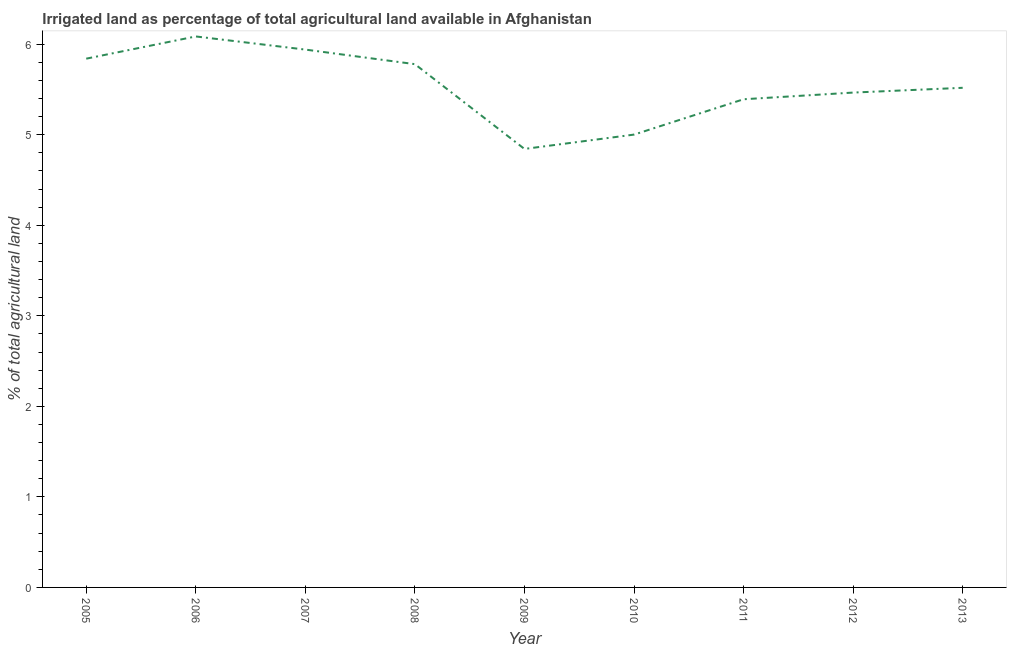What is the percentage of agricultural irrigated land in 2006?
Your answer should be very brief. 6.09. Across all years, what is the maximum percentage of agricultural irrigated land?
Your answer should be very brief. 6.09. Across all years, what is the minimum percentage of agricultural irrigated land?
Provide a short and direct response. 4.84. In which year was the percentage of agricultural irrigated land minimum?
Keep it short and to the point. 2009. What is the sum of the percentage of agricultural irrigated land?
Your answer should be compact. 49.87. What is the difference between the percentage of agricultural irrigated land in 2009 and 2010?
Offer a terse response. -0.16. What is the average percentage of agricultural irrigated land per year?
Ensure brevity in your answer.  5.54. What is the median percentage of agricultural irrigated land?
Your answer should be very brief. 5.52. In how many years, is the percentage of agricultural irrigated land greater than 3.2 %?
Make the answer very short. 9. What is the ratio of the percentage of agricultural irrigated land in 2007 to that in 2010?
Keep it short and to the point. 1.19. Is the difference between the percentage of agricultural irrigated land in 2006 and 2011 greater than the difference between any two years?
Your answer should be very brief. No. What is the difference between the highest and the second highest percentage of agricultural irrigated land?
Provide a short and direct response. 0.15. What is the difference between the highest and the lowest percentage of agricultural irrigated land?
Keep it short and to the point. 1.24. Does the percentage of agricultural irrigated land monotonically increase over the years?
Offer a very short reply. No. How many years are there in the graph?
Offer a very short reply. 9. Does the graph contain any zero values?
Your response must be concise. No. Does the graph contain grids?
Make the answer very short. No. What is the title of the graph?
Your response must be concise. Irrigated land as percentage of total agricultural land available in Afghanistan. What is the label or title of the Y-axis?
Make the answer very short. % of total agricultural land. What is the % of total agricultural land in 2005?
Provide a short and direct response. 5.84. What is the % of total agricultural land of 2006?
Offer a very short reply. 6.09. What is the % of total agricultural land of 2007?
Your answer should be very brief. 5.94. What is the % of total agricultural land in 2008?
Make the answer very short. 5.78. What is the % of total agricultural land in 2009?
Ensure brevity in your answer.  4.84. What is the % of total agricultural land in 2010?
Provide a succinct answer. 5. What is the % of total agricultural land in 2011?
Offer a very short reply. 5.39. What is the % of total agricultural land in 2012?
Your answer should be very brief. 5.47. What is the % of total agricultural land of 2013?
Your response must be concise. 5.52. What is the difference between the % of total agricultural land in 2005 and 2006?
Provide a succinct answer. -0.25. What is the difference between the % of total agricultural land in 2005 and 2007?
Your response must be concise. -0.1. What is the difference between the % of total agricultural land in 2005 and 2008?
Give a very brief answer. 0.06. What is the difference between the % of total agricultural land in 2005 and 2010?
Your answer should be compact. 0.84. What is the difference between the % of total agricultural land in 2005 and 2011?
Your answer should be very brief. 0.45. What is the difference between the % of total agricultural land in 2005 and 2012?
Make the answer very short. 0.37. What is the difference between the % of total agricultural land in 2005 and 2013?
Provide a short and direct response. 0.32. What is the difference between the % of total agricultural land in 2006 and 2007?
Provide a short and direct response. 0.15. What is the difference between the % of total agricultural land in 2006 and 2008?
Keep it short and to the point. 0.31. What is the difference between the % of total agricultural land in 2006 and 2009?
Offer a very short reply. 1.24. What is the difference between the % of total agricultural land in 2006 and 2010?
Provide a succinct answer. 1.08. What is the difference between the % of total agricultural land in 2006 and 2011?
Keep it short and to the point. 0.69. What is the difference between the % of total agricultural land in 2006 and 2012?
Your answer should be very brief. 0.62. What is the difference between the % of total agricultural land in 2006 and 2013?
Make the answer very short. 0.57. What is the difference between the % of total agricultural land in 2007 and 2008?
Make the answer very short. 0.16. What is the difference between the % of total agricultural land in 2007 and 2009?
Ensure brevity in your answer.  1.1. What is the difference between the % of total agricultural land in 2007 and 2010?
Your response must be concise. 0.94. What is the difference between the % of total agricultural land in 2007 and 2011?
Make the answer very short. 0.55. What is the difference between the % of total agricultural land in 2007 and 2012?
Offer a terse response. 0.47. What is the difference between the % of total agricultural land in 2007 and 2013?
Ensure brevity in your answer.  0.42. What is the difference between the % of total agricultural land in 2008 and 2009?
Keep it short and to the point. 0.94. What is the difference between the % of total agricultural land in 2008 and 2010?
Keep it short and to the point. 0.78. What is the difference between the % of total agricultural land in 2008 and 2011?
Your response must be concise. 0.39. What is the difference between the % of total agricultural land in 2008 and 2012?
Keep it short and to the point. 0.31. What is the difference between the % of total agricultural land in 2008 and 2013?
Make the answer very short. 0.26. What is the difference between the % of total agricultural land in 2009 and 2010?
Your answer should be very brief. -0.16. What is the difference between the % of total agricultural land in 2009 and 2011?
Offer a very short reply. -0.55. What is the difference between the % of total agricultural land in 2009 and 2012?
Offer a terse response. -0.62. What is the difference between the % of total agricultural land in 2009 and 2013?
Offer a terse response. -0.68. What is the difference between the % of total agricultural land in 2010 and 2011?
Your answer should be very brief. -0.39. What is the difference between the % of total agricultural land in 2010 and 2012?
Give a very brief answer. -0.46. What is the difference between the % of total agricultural land in 2010 and 2013?
Ensure brevity in your answer.  -0.52. What is the difference between the % of total agricultural land in 2011 and 2012?
Give a very brief answer. -0.07. What is the difference between the % of total agricultural land in 2011 and 2013?
Your answer should be very brief. -0.13. What is the difference between the % of total agricultural land in 2012 and 2013?
Make the answer very short. -0.05. What is the ratio of the % of total agricultural land in 2005 to that in 2009?
Offer a terse response. 1.21. What is the ratio of the % of total agricultural land in 2005 to that in 2010?
Provide a succinct answer. 1.17. What is the ratio of the % of total agricultural land in 2005 to that in 2011?
Make the answer very short. 1.08. What is the ratio of the % of total agricultural land in 2005 to that in 2012?
Offer a terse response. 1.07. What is the ratio of the % of total agricultural land in 2005 to that in 2013?
Keep it short and to the point. 1.06. What is the ratio of the % of total agricultural land in 2006 to that in 2007?
Ensure brevity in your answer.  1.02. What is the ratio of the % of total agricultural land in 2006 to that in 2008?
Offer a terse response. 1.05. What is the ratio of the % of total agricultural land in 2006 to that in 2009?
Make the answer very short. 1.26. What is the ratio of the % of total agricultural land in 2006 to that in 2010?
Keep it short and to the point. 1.22. What is the ratio of the % of total agricultural land in 2006 to that in 2011?
Keep it short and to the point. 1.13. What is the ratio of the % of total agricultural land in 2006 to that in 2012?
Offer a very short reply. 1.11. What is the ratio of the % of total agricultural land in 2006 to that in 2013?
Give a very brief answer. 1.1. What is the ratio of the % of total agricultural land in 2007 to that in 2008?
Offer a terse response. 1.03. What is the ratio of the % of total agricultural land in 2007 to that in 2009?
Make the answer very short. 1.23. What is the ratio of the % of total agricultural land in 2007 to that in 2010?
Offer a very short reply. 1.19. What is the ratio of the % of total agricultural land in 2007 to that in 2011?
Provide a short and direct response. 1.1. What is the ratio of the % of total agricultural land in 2007 to that in 2012?
Provide a short and direct response. 1.09. What is the ratio of the % of total agricultural land in 2007 to that in 2013?
Make the answer very short. 1.08. What is the ratio of the % of total agricultural land in 2008 to that in 2009?
Keep it short and to the point. 1.19. What is the ratio of the % of total agricultural land in 2008 to that in 2010?
Your response must be concise. 1.16. What is the ratio of the % of total agricultural land in 2008 to that in 2011?
Offer a terse response. 1.07. What is the ratio of the % of total agricultural land in 2008 to that in 2012?
Your answer should be compact. 1.06. What is the ratio of the % of total agricultural land in 2008 to that in 2013?
Offer a terse response. 1.05. What is the ratio of the % of total agricultural land in 2009 to that in 2010?
Your answer should be very brief. 0.97. What is the ratio of the % of total agricultural land in 2009 to that in 2011?
Provide a succinct answer. 0.9. What is the ratio of the % of total agricultural land in 2009 to that in 2012?
Provide a succinct answer. 0.89. What is the ratio of the % of total agricultural land in 2009 to that in 2013?
Keep it short and to the point. 0.88. What is the ratio of the % of total agricultural land in 2010 to that in 2011?
Your response must be concise. 0.93. What is the ratio of the % of total agricultural land in 2010 to that in 2012?
Keep it short and to the point. 0.92. What is the ratio of the % of total agricultural land in 2010 to that in 2013?
Your answer should be compact. 0.91. What is the ratio of the % of total agricultural land in 2011 to that in 2012?
Your answer should be compact. 0.99. 